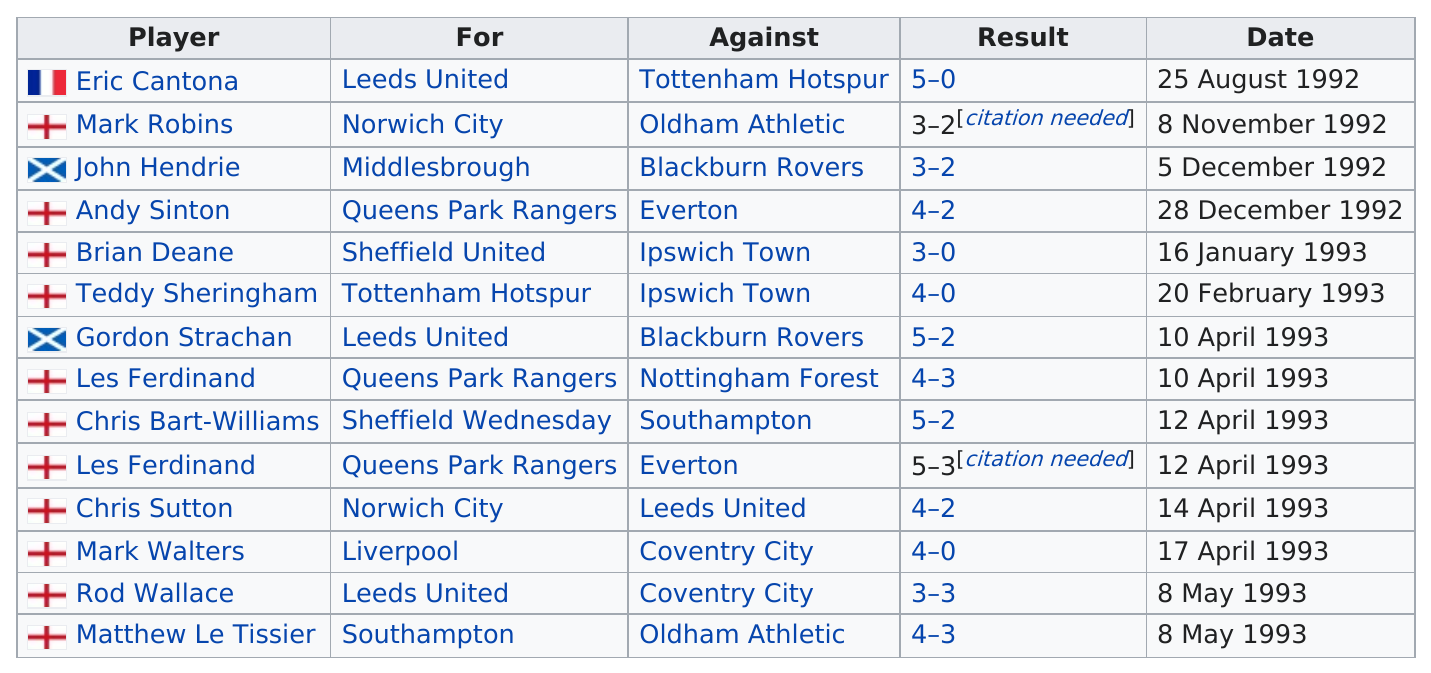Mention a couple of crucial points in this snapshot. How many games occurred in 1992? There were four games in total. John Hendrie plays for Middlesbrough. The football match between Liverpool and Coventry City resulted in the same outcome as the game between Tottenham Hotspur and Ipswich Town. Mark Robinson's result was matched by John Hendrie. The match between Queens Park Rangers and Everton ended with a score of 4-2 in favor of Queens Park Rangers. 